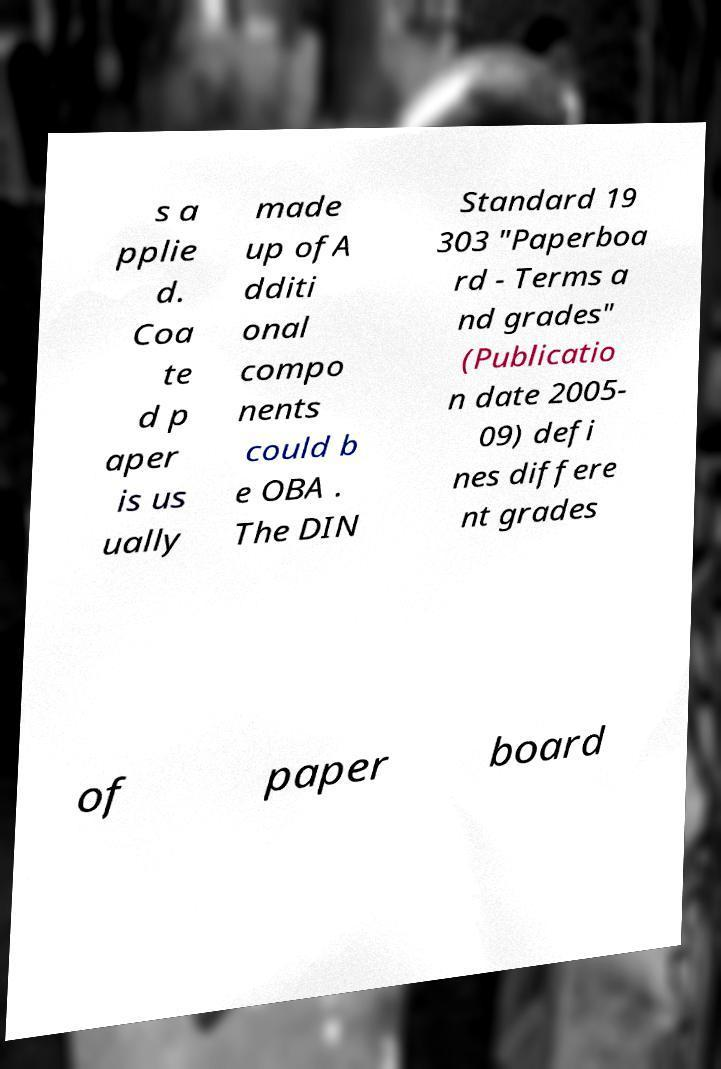Could you assist in decoding the text presented in this image and type it out clearly? s a pplie d. Coa te d p aper is us ually made up ofA dditi onal compo nents could b e OBA . The DIN Standard 19 303 "Paperboa rd - Terms a nd grades" (Publicatio n date 2005- 09) defi nes differe nt grades of paper board 